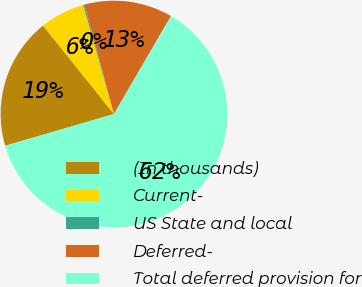Convert chart to OTSL. <chart><loc_0><loc_0><loc_500><loc_500><pie_chart><fcel>(In thousands)<fcel>Current-<fcel>US State and local<fcel>Deferred-<fcel>Total deferred provision for<nl><fcel>18.76%<fcel>6.38%<fcel>0.19%<fcel>12.57%<fcel>62.09%<nl></chart> 